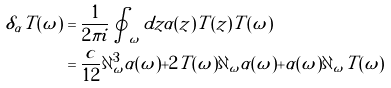Convert formula to latex. <formula><loc_0><loc_0><loc_500><loc_500>\delta _ { \alpha } T ( \omega ) & = \frac { 1 } { 2 \pi i } \oint _ { \omega } d z \alpha ( z ) T ( z ) T ( \omega ) \\ & = \frac { c } { 1 2 } \partial ^ { 3 } _ { \omega } \alpha ( \omega ) + 2 T ( \omega ) \partial _ { \omega } \alpha ( \omega ) + \alpha ( \omega ) \partial _ { \omega } T ( \omega )</formula> 